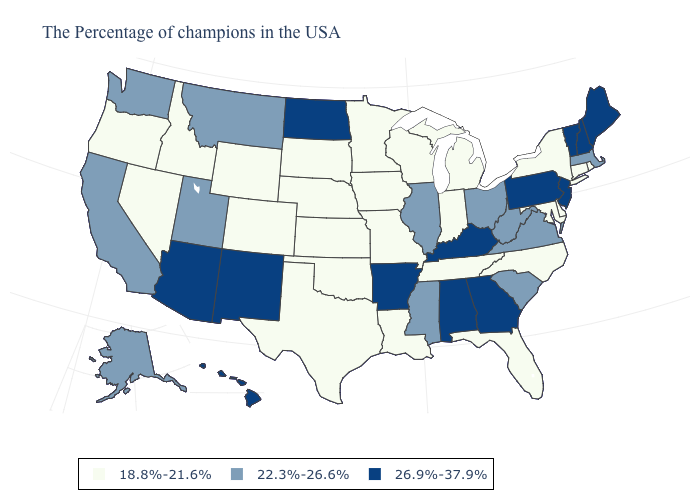Does Rhode Island have the lowest value in the Northeast?
Answer briefly. Yes. What is the highest value in the USA?
Write a very short answer. 26.9%-37.9%. Does Hawaii have a lower value than Maine?
Be succinct. No. What is the highest value in the South ?
Quick response, please. 26.9%-37.9%. Name the states that have a value in the range 22.3%-26.6%?
Concise answer only. Massachusetts, Virginia, South Carolina, West Virginia, Ohio, Illinois, Mississippi, Utah, Montana, California, Washington, Alaska. Which states have the highest value in the USA?
Answer briefly. Maine, New Hampshire, Vermont, New Jersey, Pennsylvania, Georgia, Kentucky, Alabama, Arkansas, North Dakota, New Mexico, Arizona, Hawaii. Name the states that have a value in the range 18.8%-21.6%?
Be succinct. Rhode Island, Connecticut, New York, Delaware, Maryland, North Carolina, Florida, Michigan, Indiana, Tennessee, Wisconsin, Louisiana, Missouri, Minnesota, Iowa, Kansas, Nebraska, Oklahoma, Texas, South Dakota, Wyoming, Colorado, Idaho, Nevada, Oregon. Name the states that have a value in the range 22.3%-26.6%?
Write a very short answer. Massachusetts, Virginia, South Carolina, West Virginia, Ohio, Illinois, Mississippi, Utah, Montana, California, Washington, Alaska. Name the states that have a value in the range 18.8%-21.6%?
Write a very short answer. Rhode Island, Connecticut, New York, Delaware, Maryland, North Carolina, Florida, Michigan, Indiana, Tennessee, Wisconsin, Louisiana, Missouri, Minnesota, Iowa, Kansas, Nebraska, Oklahoma, Texas, South Dakota, Wyoming, Colorado, Idaho, Nevada, Oregon. What is the value of Kansas?
Answer briefly. 18.8%-21.6%. What is the highest value in states that border Utah?
Quick response, please. 26.9%-37.9%. Name the states that have a value in the range 18.8%-21.6%?
Short answer required. Rhode Island, Connecticut, New York, Delaware, Maryland, North Carolina, Florida, Michigan, Indiana, Tennessee, Wisconsin, Louisiana, Missouri, Minnesota, Iowa, Kansas, Nebraska, Oklahoma, Texas, South Dakota, Wyoming, Colorado, Idaho, Nevada, Oregon. Does the map have missing data?
Keep it brief. No. Does Virginia have a higher value than Maine?
Quick response, please. No. What is the lowest value in the MidWest?
Quick response, please. 18.8%-21.6%. 